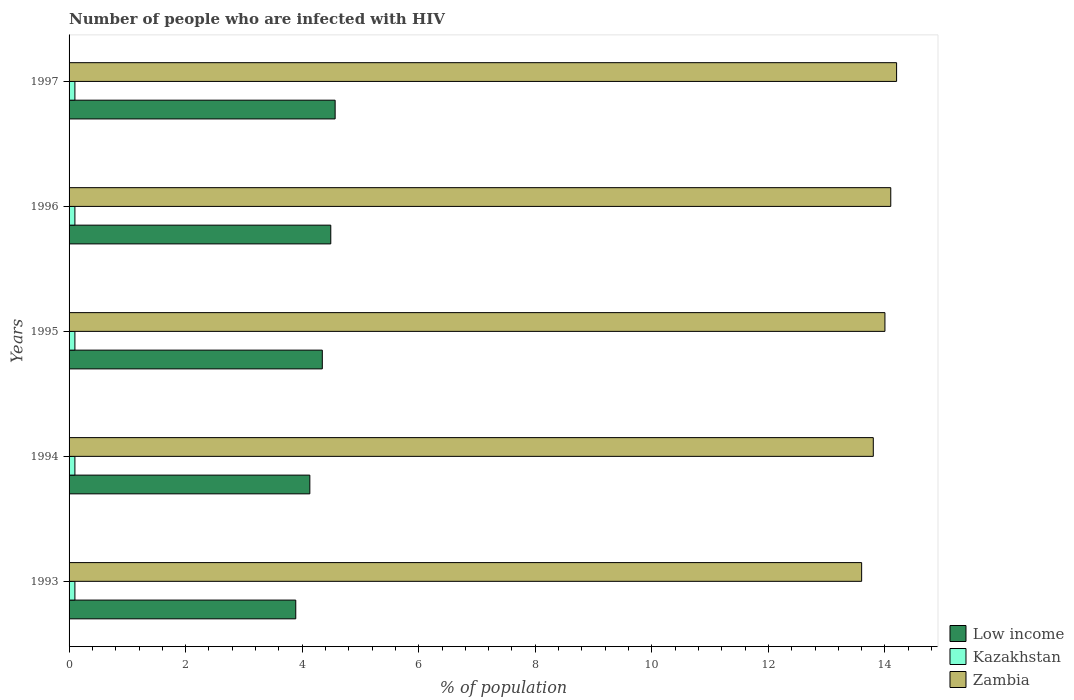How many different coloured bars are there?
Provide a succinct answer. 3. How many groups of bars are there?
Your answer should be compact. 5. Are the number of bars per tick equal to the number of legend labels?
Make the answer very short. Yes. In how many cases, is the number of bars for a given year not equal to the number of legend labels?
Give a very brief answer. 0. What is the percentage of HIV infected population in in Kazakhstan in 1996?
Ensure brevity in your answer.  0.1. Across all years, what is the maximum percentage of HIV infected population in in Zambia?
Offer a very short reply. 14.2. What is the total percentage of HIV infected population in in Low income in the graph?
Give a very brief answer. 21.42. What is the difference between the percentage of HIV infected population in in Kazakhstan in 1994 and the percentage of HIV infected population in in Low income in 1996?
Your answer should be very brief. -4.39. What is the average percentage of HIV infected population in in Zambia per year?
Ensure brevity in your answer.  13.94. In the year 1994, what is the difference between the percentage of HIV infected population in in Low income and percentage of HIV infected population in in Kazakhstan?
Your answer should be compact. 4.03. In how many years, is the percentage of HIV infected population in in Zambia greater than 7.2 %?
Your answer should be very brief. 5. What is the ratio of the percentage of HIV infected population in in Zambia in 1994 to that in 1995?
Your answer should be very brief. 0.99. Is the percentage of HIV infected population in in Low income in 1995 less than that in 1996?
Your response must be concise. Yes. Is the difference between the percentage of HIV infected population in in Low income in 1993 and 1995 greater than the difference between the percentage of HIV infected population in in Kazakhstan in 1993 and 1995?
Your answer should be compact. No. What is the difference between the highest and the second highest percentage of HIV infected population in in Zambia?
Give a very brief answer. 0.1. What is the difference between the highest and the lowest percentage of HIV infected population in in Zambia?
Ensure brevity in your answer.  0.6. Is the sum of the percentage of HIV infected population in in Kazakhstan in 1994 and 1996 greater than the maximum percentage of HIV infected population in in Low income across all years?
Ensure brevity in your answer.  No. What does the 3rd bar from the top in 1993 represents?
Give a very brief answer. Low income. What does the 3rd bar from the bottom in 1995 represents?
Make the answer very short. Zambia. How many years are there in the graph?
Give a very brief answer. 5. Are the values on the major ticks of X-axis written in scientific E-notation?
Your answer should be compact. No. Does the graph contain grids?
Provide a short and direct response. No. Where does the legend appear in the graph?
Provide a short and direct response. Bottom right. What is the title of the graph?
Ensure brevity in your answer.  Number of people who are infected with HIV. What is the label or title of the X-axis?
Make the answer very short. % of population. What is the % of population in Low income in 1993?
Ensure brevity in your answer.  3.89. What is the % of population in Zambia in 1993?
Offer a terse response. 13.6. What is the % of population of Low income in 1994?
Provide a short and direct response. 4.13. What is the % of population of Kazakhstan in 1994?
Offer a very short reply. 0.1. What is the % of population in Low income in 1995?
Offer a very short reply. 4.35. What is the % of population in Zambia in 1995?
Provide a short and direct response. 14. What is the % of population of Low income in 1996?
Make the answer very short. 4.49. What is the % of population in Kazakhstan in 1996?
Your answer should be compact. 0.1. What is the % of population in Zambia in 1996?
Your answer should be compact. 14.1. What is the % of population of Low income in 1997?
Offer a terse response. 4.57. Across all years, what is the maximum % of population in Low income?
Provide a short and direct response. 4.57. Across all years, what is the maximum % of population in Kazakhstan?
Provide a short and direct response. 0.1. Across all years, what is the maximum % of population of Zambia?
Make the answer very short. 14.2. Across all years, what is the minimum % of population in Low income?
Offer a very short reply. 3.89. Across all years, what is the minimum % of population in Kazakhstan?
Your response must be concise. 0.1. Across all years, what is the minimum % of population of Zambia?
Offer a terse response. 13.6. What is the total % of population of Low income in the graph?
Give a very brief answer. 21.42. What is the total % of population of Kazakhstan in the graph?
Offer a terse response. 0.5. What is the total % of population of Zambia in the graph?
Offer a very short reply. 69.7. What is the difference between the % of population of Low income in 1993 and that in 1994?
Provide a succinct answer. -0.24. What is the difference between the % of population of Kazakhstan in 1993 and that in 1994?
Your answer should be very brief. 0. What is the difference between the % of population of Zambia in 1993 and that in 1994?
Your answer should be compact. -0.2. What is the difference between the % of population in Low income in 1993 and that in 1995?
Give a very brief answer. -0.46. What is the difference between the % of population of Kazakhstan in 1993 and that in 1995?
Ensure brevity in your answer.  0. What is the difference between the % of population in Low income in 1993 and that in 1996?
Keep it short and to the point. -0.6. What is the difference between the % of population of Low income in 1993 and that in 1997?
Make the answer very short. -0.68. What is the difference between the % of population of Kazakhstan in 1993 and that in 1997?
Give a very brief answer. 0. What is the difference between the % of population of Low income in 1994 and that in 1995?
Ensure brevity in your answer.  -0.21. What is the difference between the % of population in Kazakhstan in 1994 and that in 1995?
Make the answer very short. 0. What is the difference between the % of population in Zambia in 1994 and that in 1995?
Give a very brief answer. -0.2. What is the difference between the % of population in Low income in 1994 and that in 1996?
Ensure brevity in your answer.  -0.36. What is the difference between the % of population of Kazakhstan in 1994 and that in 1996?
Offer a very short reply. 0. What is the difference between the % of population of Low income in 1994 and that in 1997?
Offer a very short reply. -0.43. What is the difference between the % of population of Zambia in 1994 and that in 1997?
Make the answer very short. -0.4. What is the difference between the % of population in Low income in 1995 and that in 1996?
Give a very brief answer. -0.15. What is the difference between the % of population of Kazakhstan in 1995 and that in 1996?
Your response must be concise. 0. What is the difference between the % of population in Zambia in 1995 and that in 1996?
Provide a short and direct response. -0.1. What is the difference between the % of population in Low income in 1995 and that in 1997?
Keep it short and to the point. -0.22. What is the difference between the % of population of Kazakhstan in 1995 and that in 1997?
Your answer should be very brief. 0. What is the difference between the % of population in Zambia in 1995 and that in 1997?
Your answer should be compact. -0.2. What is the difference between the % of population of Low income in 1996 and that in 1997?
Ensure brevity in your answer.  -0.07. What is the difference between the % of population in Kazakhstan in 1996 and that in 1997?
Your answer should be compact. 0. What is the difference between the % of population in Low income in 1993 and the % of population in Kazakhstan in 1994?
Make the answer very short. 3.79. What is the difference between the % of population in Low income in 1993 and the % of population in Zambia in 1994?
Give a very brief answer. -9.91. What is the difference between the % of population of Kazakhstan in 1993 and the % of population of Zambia in 1994?
Make the answer very short. -13.7. What is the difference between the % of population in Low income in 1993 and the % of population in Kazakhstan in 1995?
Your answer should be compact. 3.79. What is the difference between the % of population of Low income in 1993 and the % of population of Zambia in 1995?
Give a very brief answer. -10.11. What is the difference between the % of population of Low income in 1993 and the % of population of Kazakhstan in 1996?
Make the answer very short. 3.79. What is the difference between the % of population of Low income in 1993 and the % of population of Zambia in 1996?
Your answer should be compact. -10.21. What is the difference between the % of population of Low income in 1993 and the % of population of Kazakhstan in 1997?
Make the answer very short. 3.79. What is the difference between the % of population in Low income in 1993 and the % of population in Zambia in 1997?
Your answer should be very brief. -10.31. What is the difference between the % of population in Kazakhstan in 1993 and the % of population in Zambia in 1997?
Keep it short and to the point. -14.1. What is the difference between the % of population of Low income in 1994 and the % of population of Kazakhstan in 1995?
Ensure brevity in your answer.  4.03. What is the difference between the % of population of Low income in 1994 and the % of population of Zambia in 1995?
Keep it short and to the point. -9.87. What is the difference between the % of population in Kazakhstan in 1994 and the % of population in Zambia in 1995?
Your response must be concise. -13.9. What is the difference between the % of population in Low income in 1994 and the % of population in Kazakhstan in 1996?
Keep it short and to the point. 4.03. What is the difference between the % of population in Low income in 1994 and the % of population in Zambia in 1996?
Your answer should be compact. -9.97. What is the difference between the % of population in Kazakhstan in 1994 and the % of population in Zambia in 1996?
Ensure brevity in your answer.  -14. What is the difference between the % of population of Low income in 1994 and the % of population of Kazakhstan in 1997?
Offer a very short reply. 4.03. What is the difference between the % of population in Low income in 1994 and the % of population in Zambia in 1997?
Your answer should be very brief. -10.07. What is the difference between the % of population in Kazakhstan in 1994 and the % of population in Zambia in 1997?
Your answer should be very brief. -14.1. What is the difference between the % of population in Low income in 1995 and the % of population in Kazakhstan in 1996?
Your answer should be compact. 4.25. What is the difference between the % of population in Low income in 1995 and the % of population in Zambia in 1996?
Your answer should be compact. -9.75. What is the difference between the % of population in Kazakhstan in 1995 and the % of population in Zambia in 1996?
Provide a succinct answer. -14. What is the difference between the % of population of Low income in 1995 and the % of population of Kazakhstan in 1997?
Offer a very short reply. 4.25. What is the difference between the % of population of Low income in 1995 and the % of population of Zambia in 1997?
Give a very brief answer. -9.85. What is the difference between the % of population in Kazakhstan in 1995 and the % of population in Zambia in 1997?
Offer a terse response. -14.1. What is the difference between the % of population in Low income in 1996 and the % of population in Kazakhstan in 1997?
Give a very brief answer. 4.39. What is the difference between the % of population in Low income in 1996 and the % of population in Zambia in 1997?
Ensure brevity in your answer.  -9.71. What is the difference between the % of population in Kazakhstan in 1996 and the % of population in Zambia in 1997?
Your response must be concise. -14.1. What is the average % of population in Low income per year?
Keep it short and to the point. 4.28. What is the average % of population in Kazakhstan per year?
Offer a very short reply. 0.1. What is the average % of population of Zambia per year?
Provide a succinct answer. 13.94. In the year 1993, what is the difference between the % of population in Low income and % of population in Kazakhstan?
Ensure brevity in your answer.  3.79. In the year 1993, what is the difference between the % of population in Low income and % of population in Zambia?
Your answer should be very brief. -9.71. In the year 1994, what is the difference between the % of population in Low income and % of population in Kazakhstan?
Your answer should be compact. 4.03. In the year 1994, what is the difference between the % of population in Low income and % of population in Zambia?
Your answer should be compact. -9.67. In the year 1994, what is the difference between the % of population of Kazakhstan and % of population of Zambia?
Provide a succinct answer. -13.7. In the year 1995, what is the difference between the % of population of Low income and % of population of Kazakhstan?
Keep it short and to the point. 4.25. In the year 1995, what is the difference between the % of population of Low income and % of population of Zambia?
Make the answer very short. -9.65. In the year 1996, what is the difference between the % of population in Low income and % of population in Kazakhstan?
Your answer should be very brief. 4.39. In the year 1996, what is the difference between the % of population in Low income and % of population in Zambia?
Provide a succinct answer. -9.61. In the year 1996, what is the difference between the % of population in Kazakhstan and % of population in Zambia?
Offer a terse response. -14. In the year 1997, what is the difference between the % of population in Low income and % of population in Kazakhstan?
Offer a terse response. 4.47. In the year 1997, what is the difference between the % of population of Low income and % of population of Zambia?
Make the answer very short. -9.63. In the year 1997, what is the difference between the % of population of Kazakhstan and % of population of Zambia?
Keep it short and to the point. -14.1. What is the ratio of the % of population in Low income in 1993 to that in 1994?
Your answer should be very brief. 0.94. What is the ratio of the % of population of Zambia in 1993 to that in 1994?
Offer a terse response. 0.99. What is the ratio of the % of population in Low income in 1993 to that in 1995?
Offer a terse response. 0.9. What is the ratio of the % of population of Zambia in 1993 to that in 1995?
Your answer should be very brief. 0.97. What is the ratio of the % of population in Low income in 1993 to that in 1996?
Your answer should be very brief. 0.87. What is the ratio of the % of population of Kazakhstan in 1993 to that in 1996?
Offer a very short reply. 1. What is the ratio of the % of population in Zambia in 1993 to that in 1996?
Your answer should be compact. 0.96. What is the ratio of the % of population of Low income in 1993 to that in 1997?
Your answer should be compact. 0.85. What is the ratio of the % of population of Kazakhstan in 1993 to that in 1997?
Make the answer very short. 1. What is the ratio of the % of population in Zambia in 1993 to that in 1997?
Provide a short and direct response. 0.96. What is the ratio of the % of population in Low income in 1994 to that in 1995?
Your response must be concise. 0.95. What is the ratio of the % of population in Kazakhstan in 1994 to that in 1995?
Give a very brief answer. 1. What is the ratio of the % of population of Zambia in 1994 to that in 1995?
Make the answer very short. 0.99. What is the ratio of the % of population in Low income in 1994 to that in 1996?
Make the answer very short. 0.92. What is the ratio of the % of population in Kazakhstan in 1994 to that in 1996?
Offer a terse response. 1. What is the ratio of the % of population in Zambia in 1994 to that in 1996?
Offer a terse response. 0.98. What is the ratio of the % of population in Low income in 1994 to that in 1997?
Your response must be concise. 0.91. What is the ratio of the % of population in Kazakhstan in 1994 to that in 1997?
Make the answer very short. 1. What is the ratio of the % of population in Zambia in 1994 to that in 1997?
Your answer should be very brief. 0.97. What is the ratio of the % of population in Kazakhstan in 1995 to that in 1996?
Make the answer very short. 1. What is the ratio of the % of population in Zambia in 1995 to that in 1996?
Offer a very short reply. 0.99. What is the ratio of the % of population in Low income in 1995 to that in 1997?
Ensure brevity in your answer.  0.95. What is the ratio of the % of population in Kazakhstan in 1995 to that in 1997?
Offer a terse response. 1. What is the ratio of the % of population of Zambia in 1995 to that in 1997?
Offer a terse response. 0.99. What is the ratio of the % of population in Low income in 1996 to that in 1997?
Give a very brief answer. 0.98. What is the difference between the highest and the second highest % of population of Low income?
Provide a succinct answer. 0.07. What is the difference between the highest and the lowest % of population in Low income?
Ensure brevity in your answer.  0.68. What is the difference between the highest and the lowest % of population of Zambia?
Give a very brief answer. 0.6. 